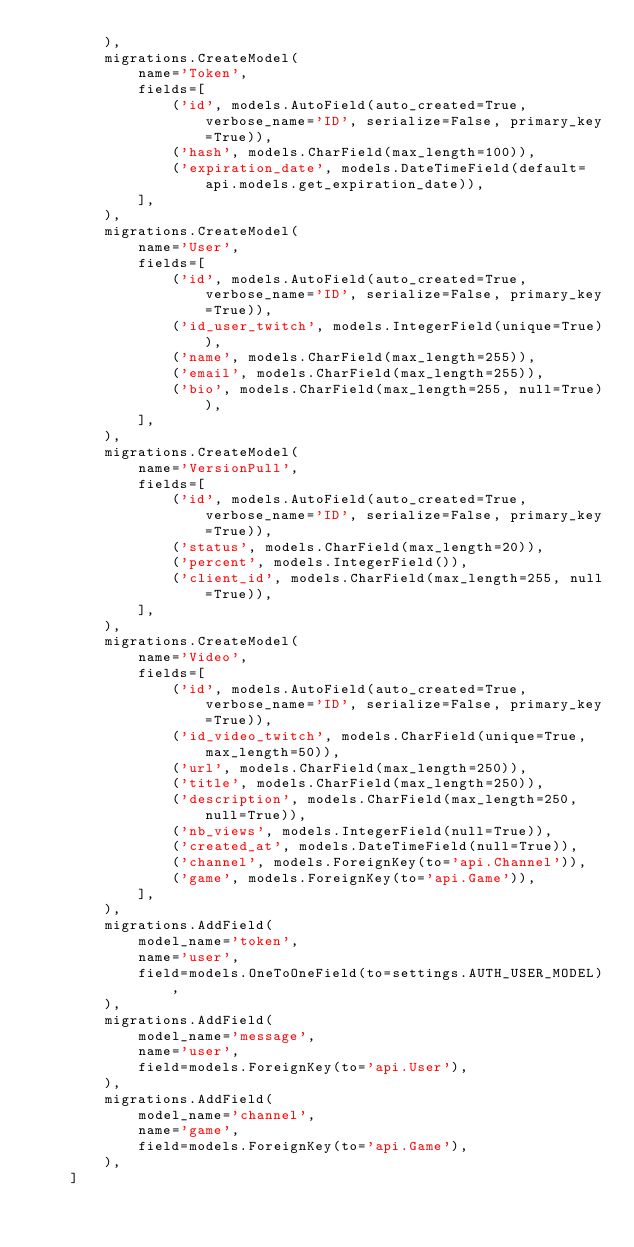Convert code to text. <code><loc_0><loc_0><loc_500><loc_500><_Python_>        ),
        migrations.CreateModel(
            name='Token',
            fields=[
                ('id', models.AutoField(auto_created=True, verbose_name='ID', serialize=False, primary_key=True)),
                ('hash', models.CharField(max_length=100)),
                ('expiration_date', models.DateTimeField(default=api.models.get_expiration_date)),
            ],
        ),
        migrations.CreateModel(
            name='User',
            fields=[
                ('id', models.AutoField(auto_created=True, verbose_name='ID', serialize=False, primary_key=True)),
                ('id_user_twitch', models.IntegerField(unique=True)),
                ('name', models.CharField(max_length=255)),
                ('email', models.CharField(max_length=255)),
                ('bio', models.CharField(max_length=255, null=True)),
            ],
        ),
        migrations.CreateModel(
            name='VersionPull',
            fields=[
                ('id', models.AutoField(auto_created=True, verbose_name='ID', serialize=False, primary_key=True)),
                ('status', models.CharField(max_length=20)),
                ('percent', models.IntegerField()),
                ('client_id', models.CharField(max_length=255, null=True)),
            ],
        ),
        migrations.CreateModel(
            name='Video',
            fields=[
                ('id', models.AutoField(auto_created=True, verbose_name='ID', serialize=False, primary_key=True)),
                ('id_video_twitch', models.CharField(unique=True, max_length=50)),
                ('url', models.CharField(max_length=250)),
                ('title', models.CharField(max_length=250)),
                ('description', models.CharField(max_length=250, null=True)),
                ('nb_views', models.IntegerField(null=True)),
                ('created_at', models.DateTimeField(null=True)),
                ('channel', models.ForeignKey(to='api.Channel')),
                ('game', models.ForeignKey(to='api.Game')),
            ],
        ),
        migrations.AddField(
            model_name='token',
            name='user',
            field=models.OneToOneField(to=settings.AUTH_USER_MODEL),
        ),
        migrations.AddField(
            model_name='message',
            name='user',
            field=models.ForeignKey(to='api.User'),
        ),
        migrations.AddField(
            model_name='channel',
            name='game',
            field=models.ForeignKey(to='api.Game'),
        ),
    ]
</code> 